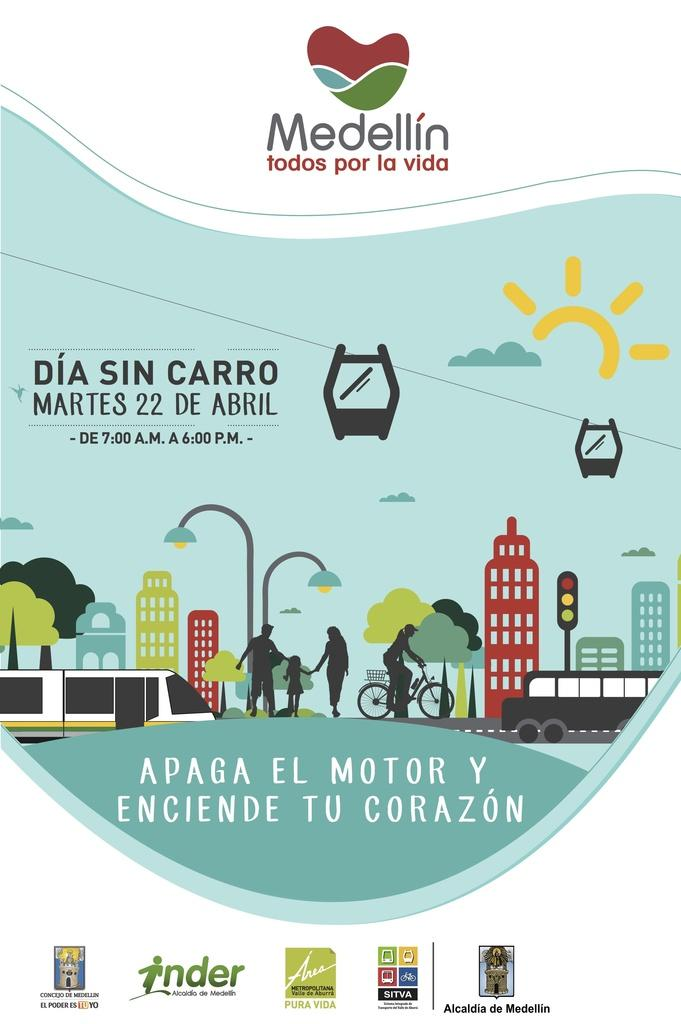Provide a one-sentence caption for the provided image. April 22 is the date of DIA SIN CARRO as advertised by Medellin whose motto is "todos por la vida". 